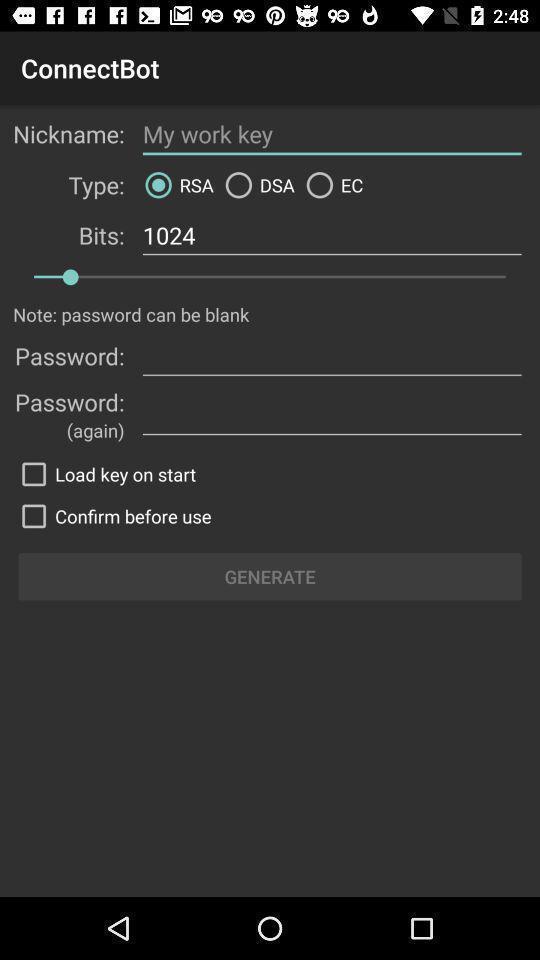Summarize the main components in this picture. Screen showing configuration settings of remote connect app. 